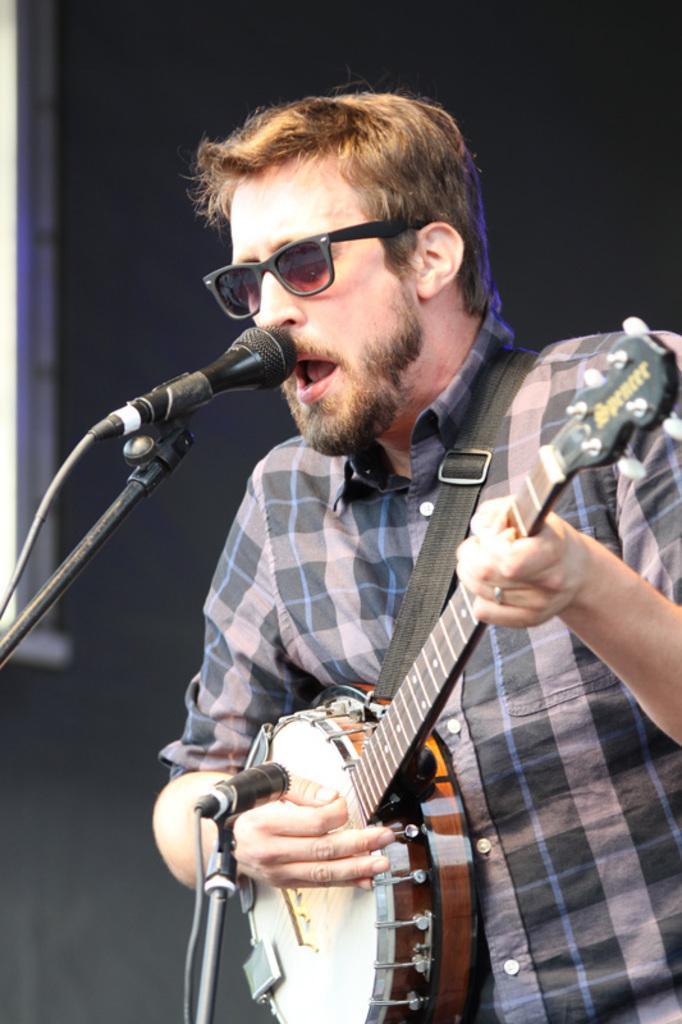Please provide a concise description of this image. In this image, we can see a man is playing a music instrument and singing in-front of a microphone. Here we can see rod and wire. Background we can see black color. 